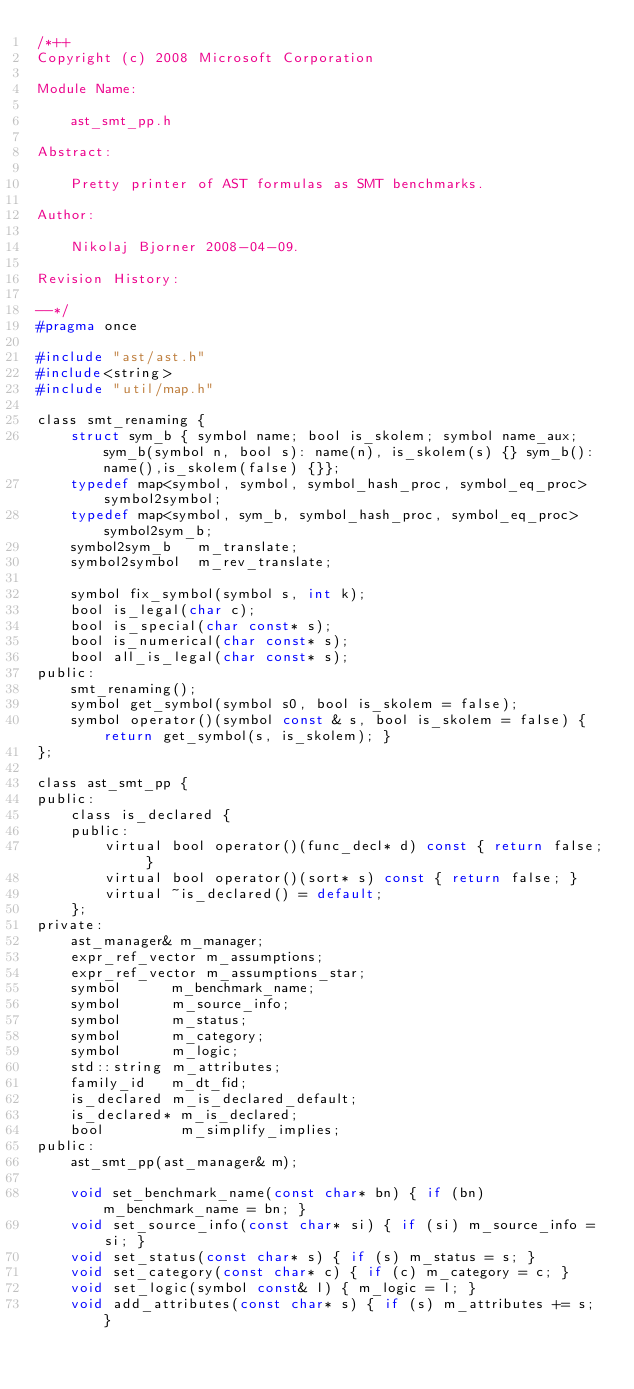<code> <loc_0><loc_0><loc_500><loc_500><_C_>/*++
Copyright (c) 2008 Microsoft Corporation

Module Name:

    ast_smt_pp.h

Abstract:

    Pretty printer of AST formulas as SMT benchmarks.

Author:

    Nikolaj Bjorner 2008-04-09.

Revision History:

--*/
#pragma once

#include "ast/ast.h"
#include<string>
#include "util/map.h"

class smt_renaming {
    struct sym_b { symbol name; bool is_skolem; symbol name_aux; sym_b(symbol n, bool s): name(n), is_skolem(s) {} sym_b():name(),is_skolem(false) {}};
    typedef map<symbol, symbol, symbol_hash_proc, symbol_eq_proc> symbol2symbol;
    typedef map<symbol, sym_b, symbol_hash_proc, symbol_eq_proc> symbol2sym_b;
    symbol2sym_b   m_translate;
    symbol2symbol  m_rev_translate;

    symbol fix_symbol(symbol s, int k);
    bool is_legal(char c);
    bool is_special(char const* s);
    bool is_numerical(char const* s);
    bool all_is_legal(char const* s);
public:
    smt_renaming();
    symbol get_symbol(symbol s0, bool is_skolem = false);
    symbol operator()(symbol const & s, bool is_skolem = false) { return get_symbol(s, is_skolem); }
};

class ast_smt_pp {
public:
    class is_declared { 
    public:
        virtual bool operator()(func_decl* d) const { return false; }
        virtual bool operator()(sort* s) const { return false; }
        virtual ~is_declared() = default;
    };
private:
    ast_manager& m_manager;
    expr_ref_vector m_assumptions;
    expr_ref_vector m_assumptions_star;
    symbol      m_benchmark_name;
    symbol      m_source_info;
    symbol      m_status;
    symbol      m_category;
    symbol      m_logic;
    std::string m_attributes;
    family_id   m_dt_fid;
    is_declared m_is_declared_default;
    is_declared* m_is_declared;
    bool         m_simplify_implies;
public:
    ast_smt_pp(ast_manager& m);

    void set_benchmark_name(const char* bn) { if (bn) m_benchmark_name = bn; }
    void set_source_info(const char* si) { if (si) m_source_info = si; }
    void set_status(const char* s) { if (s) m_status = s; }
    void set_category(const char* c) { if (c) m_category = c; }
    void set_logic(symbol const& l) { m_logic = l; }
    void add_attributes(const char* s) { if (s) m_attributes += s; }</code> 